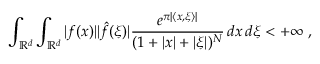<formula> <loc_0><loc_0><loc_500><loc_500>\int _ { \mathbb { R } ^ { d } } \int _ { \mathbb { R } ^ { d } } | f ( x ) | | { \hat { f } } ( \xi ) | { \frac { e ^ { \pi | \langle x , \xi \rangle | } } { ( 1 + | x | + | \xi | ) ^ { N } } } \, d x \, d \xi < + \infty ,</formula> 